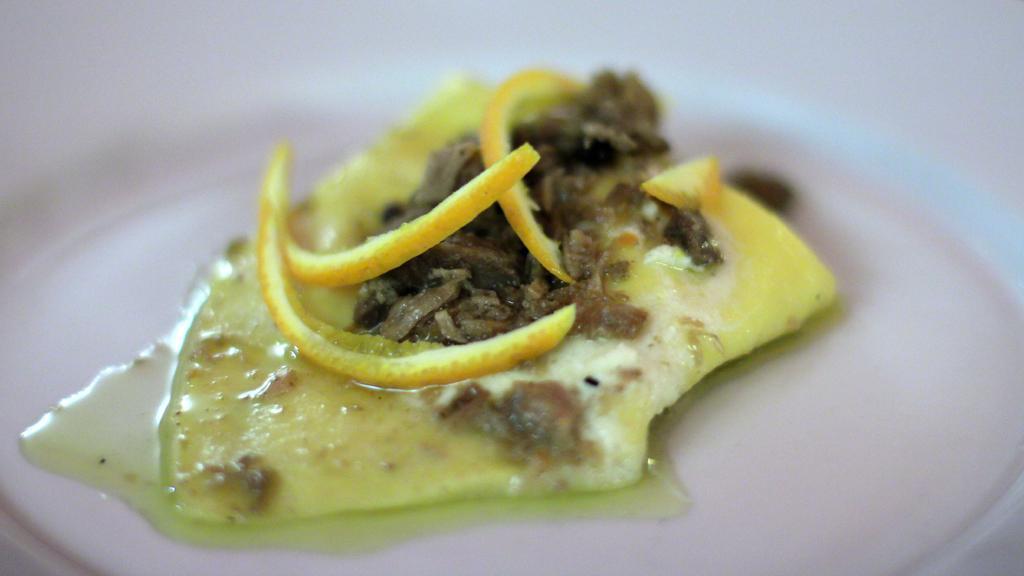In one or two sentences, can you explain what this image depicts? In this image, we can see some food on the blur background. 